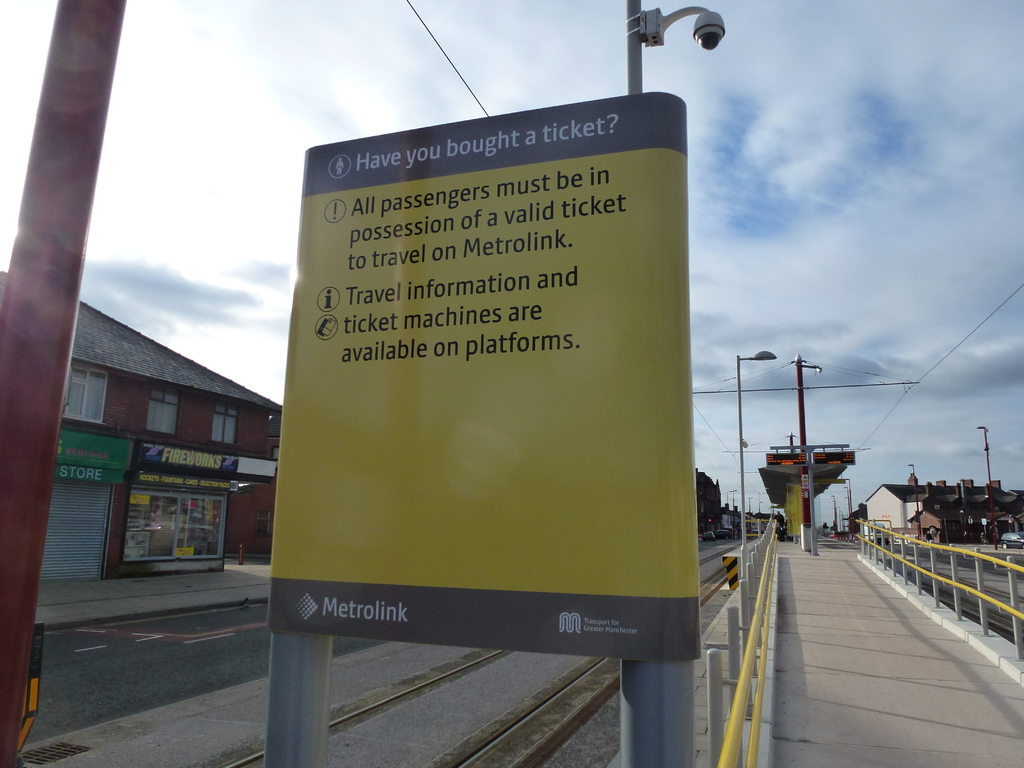What's happening in the scene? The image portrays a bustling Metrolink station on a clear day, evidenced by the bright, cloud-streaked sky. The focal point is a vibrantly colored yellow sign prominently placed alongside the track, commanding the attention of passengers. It lists imperative instructions stating that all passengers must possess valid tickets before boarding, along with a reminder about the availability of travel information and ticket machines on the platform. In the background, the urban setting is visible, with shops lining the street, adding a layer of everyday life to the scene which situates the station as an integral part of the community's daily commute. 